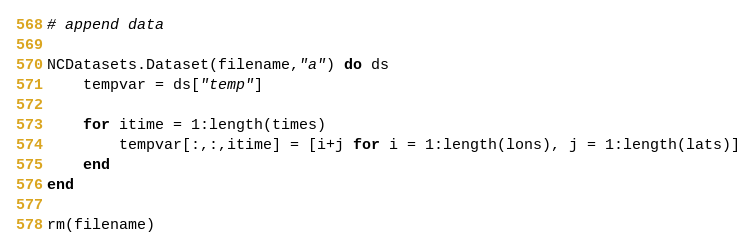<code> <loc_0><loc_0><loc_500><loc_500><_Julia_>

# append data

NCDatasets.Dataset(filename,"a") do ds
    tempvar = ds["temp"]

    for itime = 1:length(times)
        tempvar[:,:,itime] = [i+j for i = 1:length(lons), j = 1:length(lats)]
    end
end

rm(filename)
</code> 